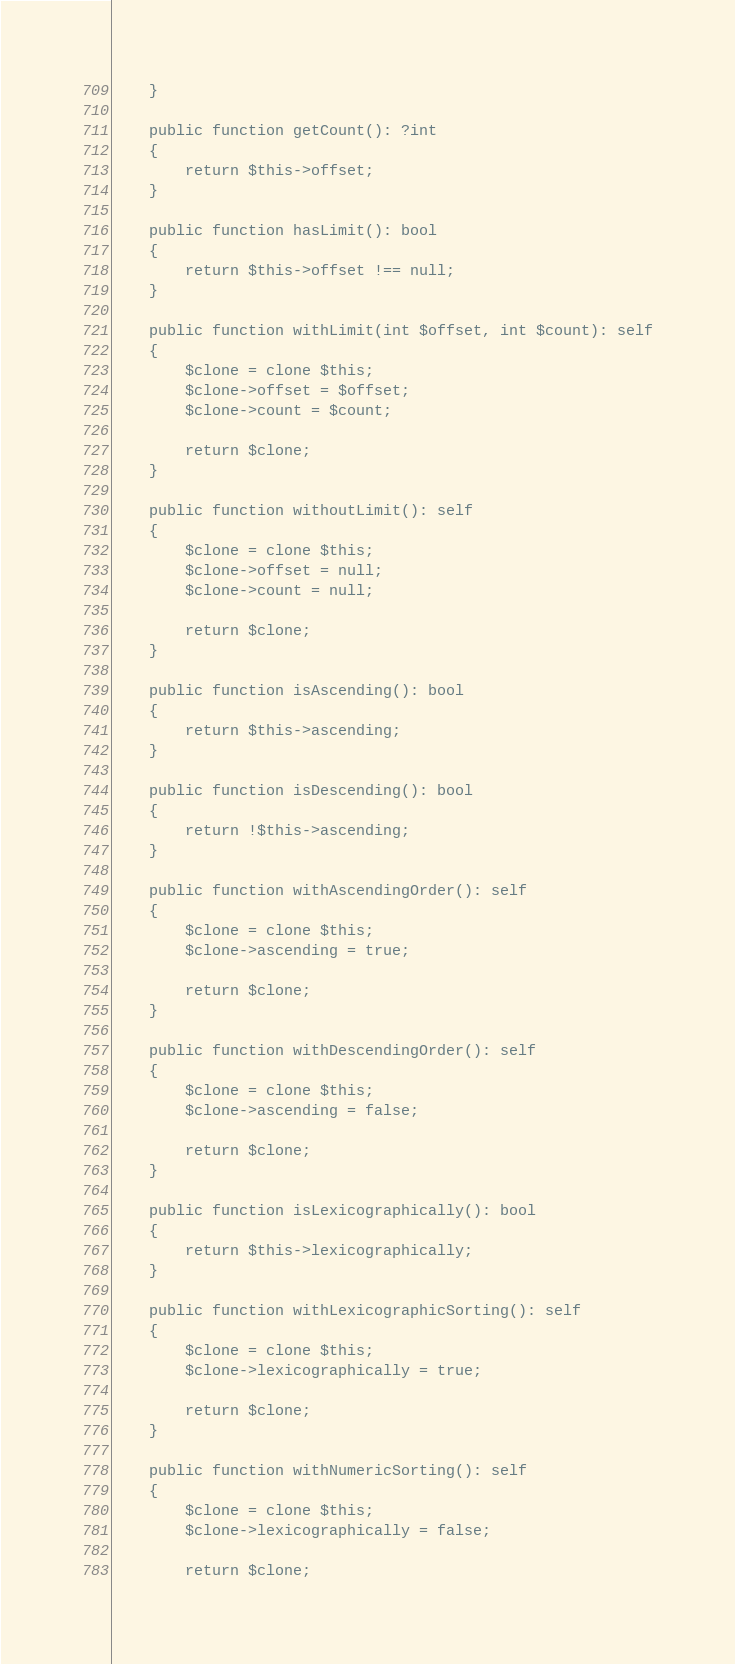<code> <loc_0><loc_0><loc_500><loc_500><_PHP_>    }

    public function getCount(): ?int
    {
        return $this->offset;
    }

    public function hasLimit(): bool
    {
        return $this->offset !== null;
    }

    public function withLimit(int $offset, int $count): self
    {
        $clone = clone $this;
        $clone->offset = $offset;
        $clone->count = $count;

        return $clone;
    }

    public function withoutLimit(): self
    {
        $clone = clone $this;
        $clone->offset = null;
        $clone->count = null;

        return $clone;
    }

    public function isAscending(): bool
    {
        return $this->ascending;
    }

    public function isDescending(): bool
    {
        return !$this->ascending;
    }

    public function withAscendingOrder(): self
    {
        $clone = clone $this;
        $clone->ascending = true;

        return $clone;
    }

    public function withDescendingOrder(): self
    {
        $clone = clone $this;
        $clone->ascending = false;

        return $clone;
    }

    public function isLexicographically(): bool
    {
        return $this->lexicographically;
    }

    public function withLexicographicSorting(): self
    {
        $clone = clone $this;
        $clone->lexicographically = true;

        return $clone;
    }

    public function withNumericSorting(): self
    {
        $clone = clone $this;
        $clone->lexicographically = false;

        return $clone;</code> 